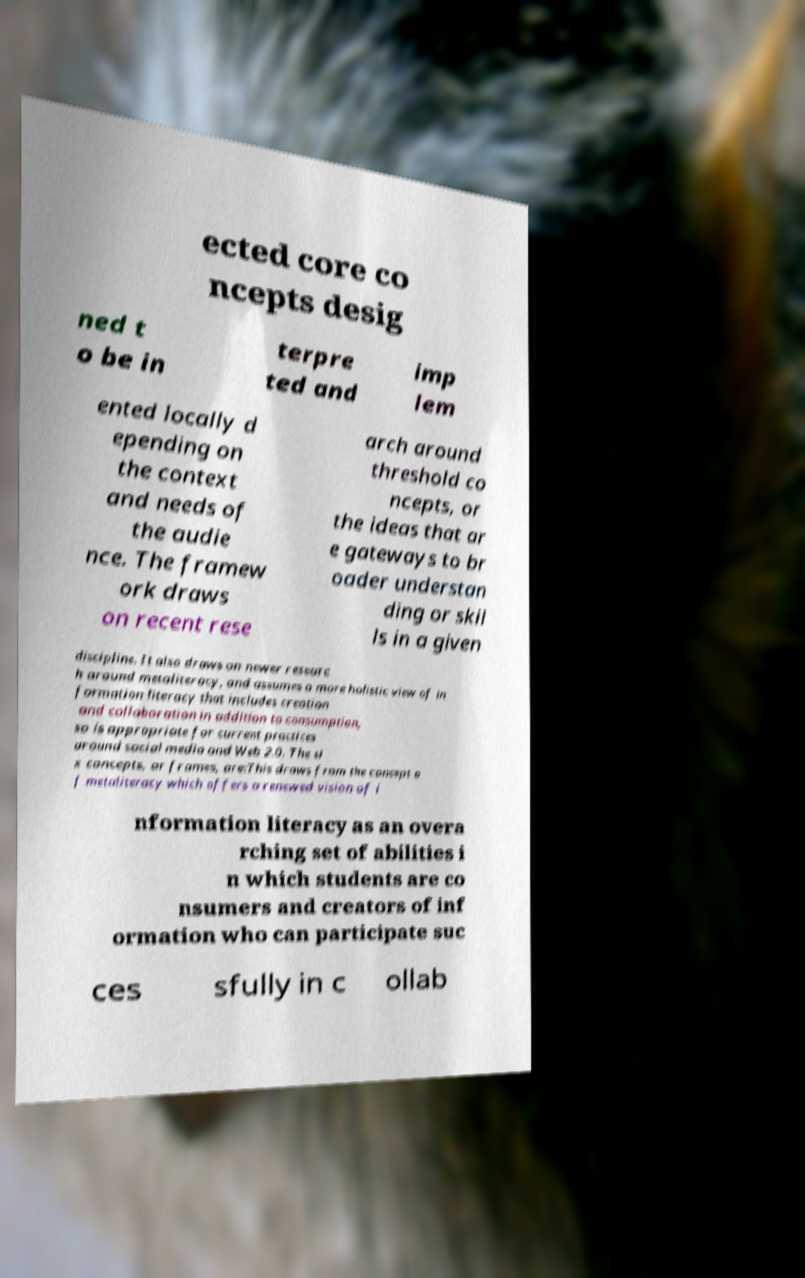Could you assist in decoding the text presented in this image and type it out clearly? ected core co ncepts desig ned t o be in terpre ted and imp lem ented locally d epending on the context and needs of the audie nce. The framew ork draws on recent rese arch around threshold co ncepts, or the ideas that ar e gateways to br oader understan ding or skil ls in a given discipline. It also draws on newer researc h around metaliteracy, and assumes a more holistic view of in formation literacy that includes creation and collaboration in addition to consumption, so is appropriate for current practices around social media and Web 2.0. The si x concepts, or frames, are:This draws from the concept o f metaliteracy which offers a renewed vision of i nformation literacy as an overa rching set of abilities i n which students are co nsumers and creators of inf ormation who can participate suc ces sfully in c ollab 